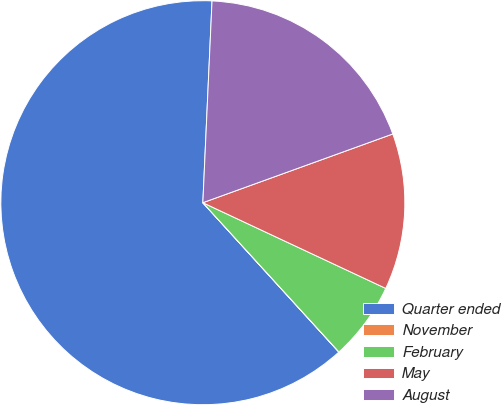<chart> <loc_0><loc_0><loc_500><loc_500><pie_chart><fcel>Quarter ended<fcel>November<fcel>February<fcel>May<fcel>August<nl><fcel>62.48%<fcel>0.01%<fcel>6.26%<fcel>12.5%<fcel>18.75%<nl></chart> 